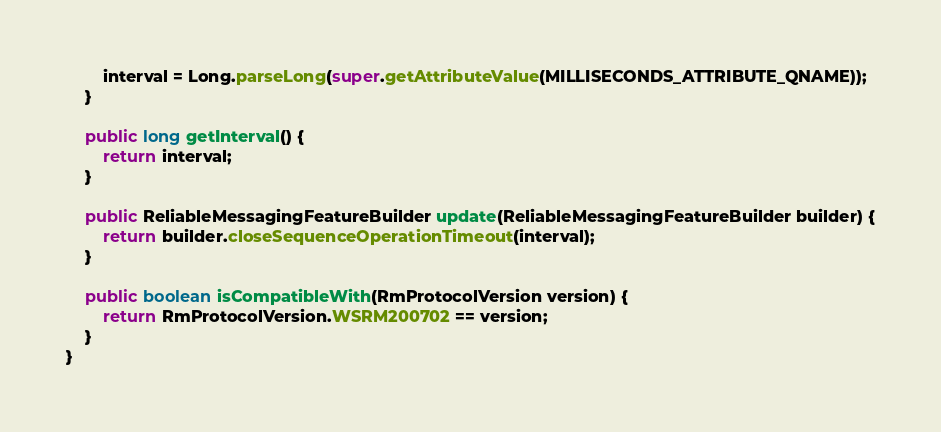<code> <loc_0><loc_0><loc_500><loc_500><_Java_>        interval = Long.parseLong(super.getAttributeValue(MILLISECONDS_ATTRIBUTE_QNAME));
    }

    public long getInterval() {
        return interval;
    }

    public ReliableMessagingFeatureBuilder update(ReliableMessagingFeatureBuilder builder) {
        return builder.closeSequenceOperationTimeout(interval);
    }

    public boolean isCompatibleWith(RmProtocolVersion version) {
        return RmProtocolVersion.WSRM200702 == version;
    }
}
</code> 